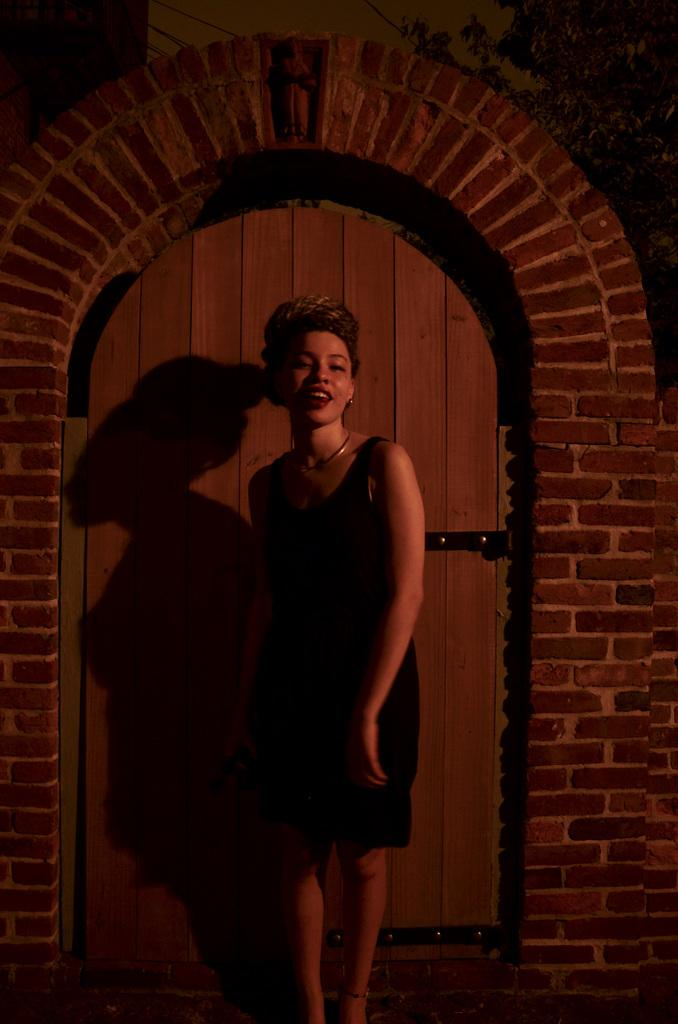Who is present in the image? There is a woman in the image. What is the woman doing in the image? The woman is standing and smiling. What color clothes is the woman wearing? The woman is wearing black color clothes. What can be seen in the background of the image? There is a door and other objects in the background of the image. What is the woman reading in the image? There is no indication in the image that the woman is reading anything. 